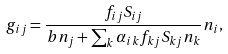<formula> <loc_0><loc_0><loc_500><loc_500>g _ { i j } = \frac { f _ { i j } S _ { i j } } { b n _ { j } + \sum _ { k } \alpha _ { i k } f _ { k j } S _ { k j } n _ { k } } n _ { i } ,</formula> 